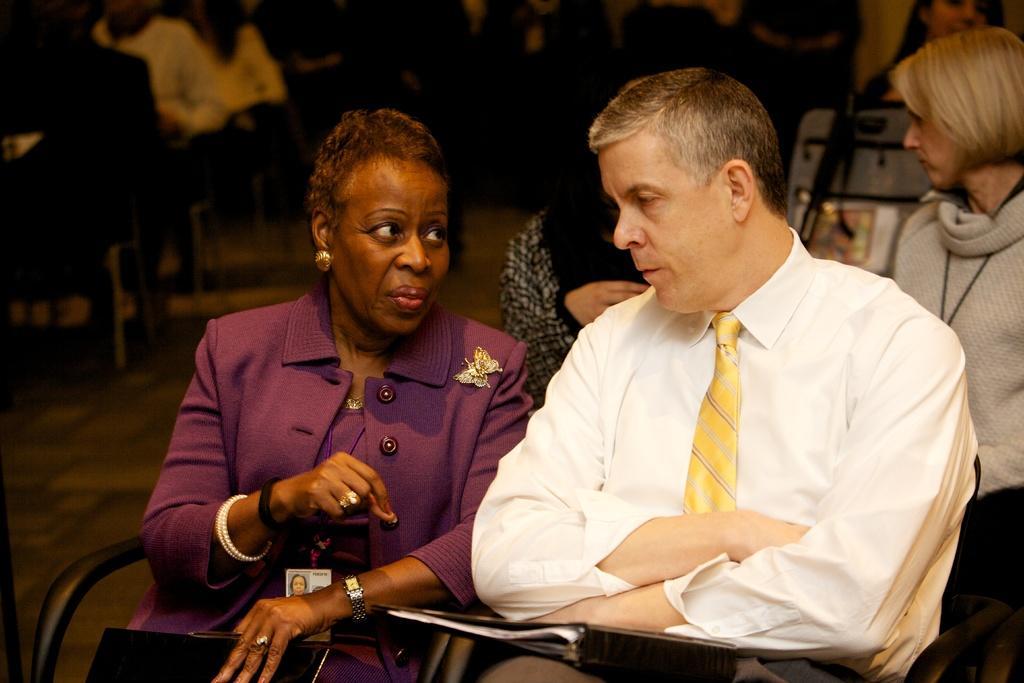How would you summarize this image in a sentence or two? In the image we can see there are people sitting and they are wearing clothes. On the left side, we can see the woman, she is wearing earrings, finger ring, wrist watch, bracelet, identity card and she is holding an object in the hands. There are many chairs and the background is slightly blurred. 